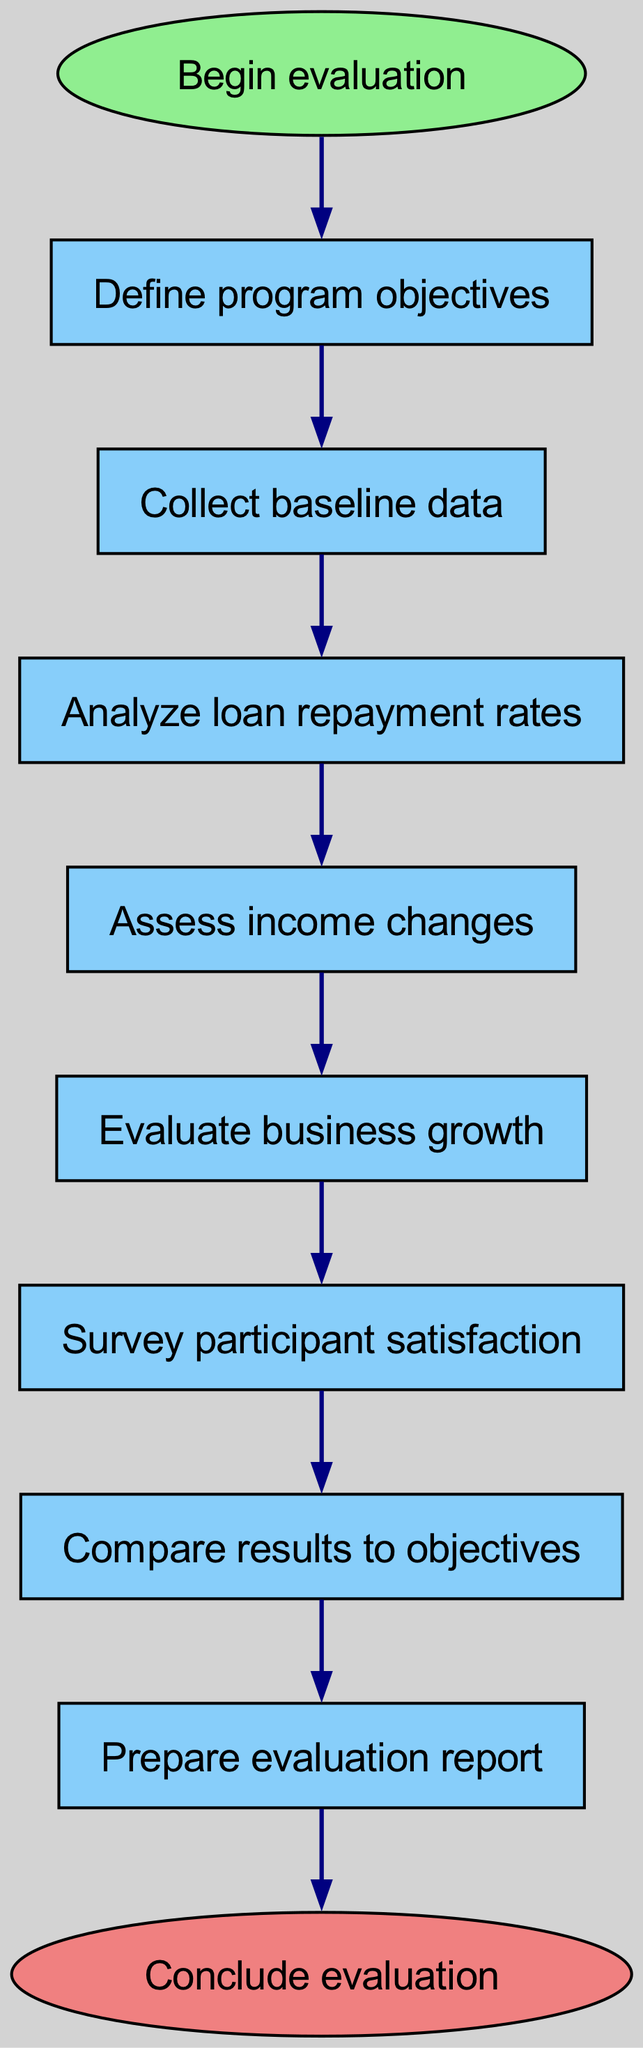What is the starting point of the evaluation process? The starting point is clearly labeled as "Begin evaluation" in the diagram, indicating the entry into the evaluation process.
Answer: Begin evaluation What is the number of nodes in the diagram? By counting all the individual process steps from the start to the end, there are eight nodes in total: one start node, six process nodes, and one end node.
Answer: Eight What is the last step in the evaluation process? The last step is indicated clearly as "Prepare evaluation report," followed by the end node, which confirms this as the final action in the process.
Answer: Prepare evaluation report Which process directly follows "Survey participant satisfaction"? The diagram shows that the process that directly follows "Survey participant satisfaction" is "Compare results to objectives," as indicated by the directed edge connecting these two steps.
Answer: Compare results to objectives How many times is data analysis involved in the flow? Data analysis is represented once in the flow with the step "Analyze loan repayment rates," making it a singular occurrence within the evaluation process.
Answer: Once What are the first two steps in the evaluation of the rural microfinance program? The first two steps are "Define program objectives" and "Collect baseline data," which are sequentially laid out one after the other in the initial processing stages of the evaluation.
Answer: Define program objectives and Collect baseline data What is the relationship between "Assess income changes" and "Evaluate business growth"? The diagram depicts a linear progression where "Assess income changes" is directly followed by "Evaluate business growth," showing a sequential relationship in the evaluation timeline.
Answer: Sequential relationship What happens immediately after defining program objectives? According to the diagram, after defining program objectives, the next step is to collect baseline data, indicating a direct sequencing of actions in the evaluation.
Answer: Collect baseline data What is the significance of the start and end nodes in this flow chart? The start node signifies the initiation of the evaluation process, while the end node marks its conclusion, delineating the boundaries of the overall evaluation flow.
Answer: Initiation and conclusion 